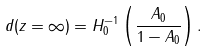Convert formula to latex. <formula><loc_0><loc_0><loc_500><loc_500>d ( z = \infty ) = H _ { 0 } ^ { - 1 } \left ( \frac { A _ { 0 } } { 1 - A _ { 0 } } \right ) .</formula> 